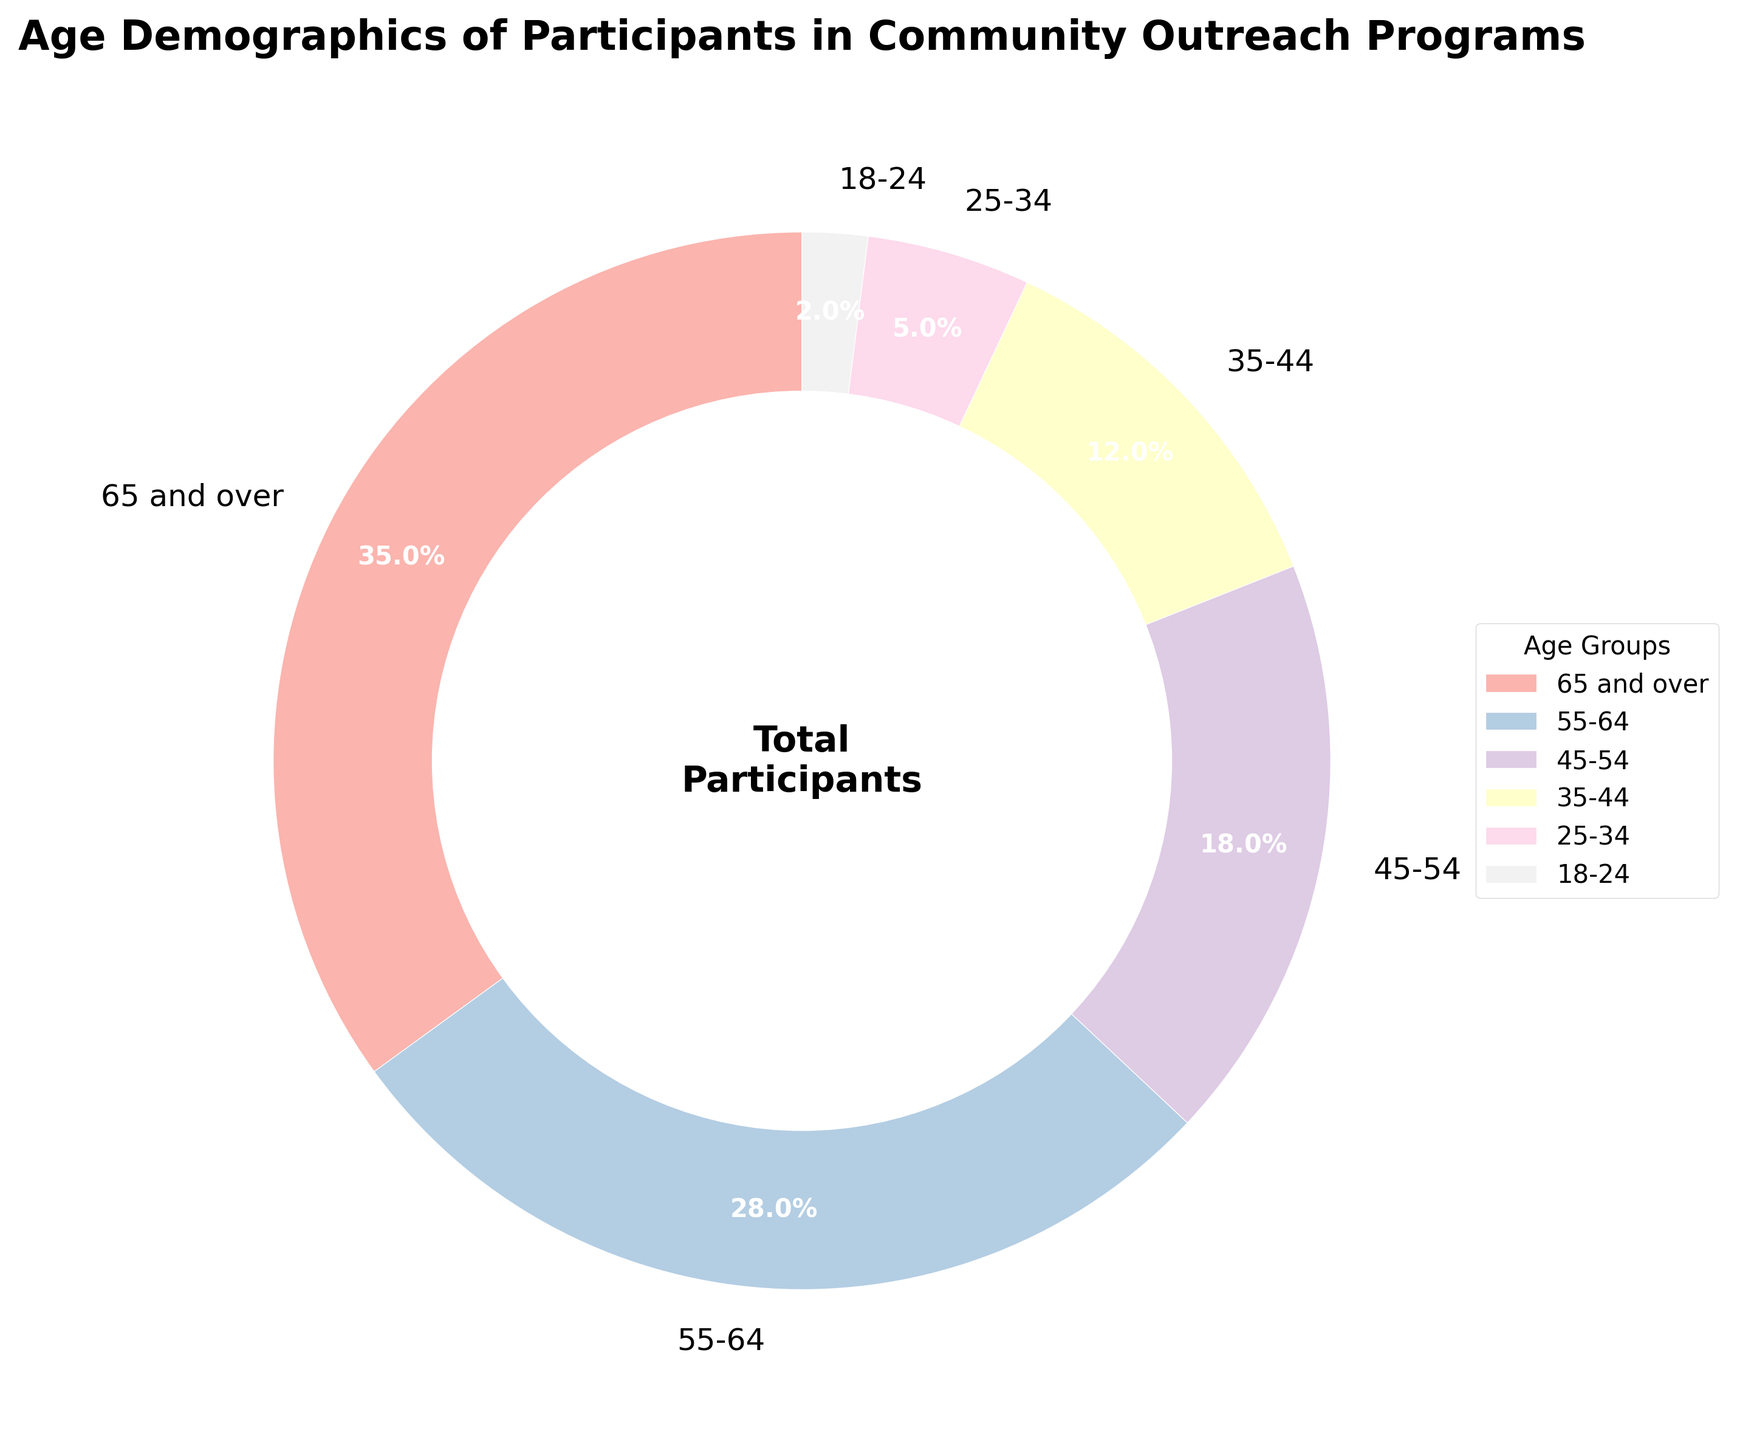What age group makes up the largest percentage of participants? The largest wedge corresponds to the 65 and over age group, making up 35% of the participants.
Answer: 65 and over What two age groups combined make up more than half of the participants? The 65 and over group is 35% and the 55-64 group is 28%. Combined, they add up to 63%, which is more than half.
Answer: 65 and over, 55-64 How much more percentage does the 65 and over group have compared to the 18-24 group? The 65 and over group is 35%, and the 18-24 group is 2%. The difference in percentage is 35% - 2% = 33%.
Answer: 33% Which age group contributes the least to the participants? The smallest wedge represents the 18-24 age group, making up 2% of the participants.
Answer: 18-24 What is the combined percentage of participants aged 25-34 and 35-44? The 25-34 group is 5% and the 35-44 group is 12%. Combined, they add up to 5% + 12% = 17%.
Answer: 17% Are there more participants aged 45-54 or aged 25-34 and 35-44 combined? The 45-54 group is 18%, and the combined 25-34 and 35-44 groups are 17%. Since 18% is greater than 17%, there are more participants aged 45-54.
Answer: 45-54 What is the ratio of participants aged 55-64 to those aged 25-34? The 55-64 group is 28%, and the 25-34 group is 5%. The ratio is 28 to 5, or 28:5.
Answer: 28:5 Which two age groups have almost the same percentage of participants? The wedges for the 45-54 (18%) and 35-44 (12%) groups have almost similar percentages considering larger splits, but the exact comparison shows they differ more. Checking smaller splits, no groups have almost identical values.
Answer: None What percentage of participants are under the age of 35? The 18-24 group is 2% and the 25-34 group is 5%. Combined, they add up to 2% + 5% = 7%.
Answer: 7% If the 55-64 group had 5% more participants, what would the new percentage be for this group? The current percentage is 28%. Adding 5% would make it 28% + 5% = 33%.
Answer: 33% 